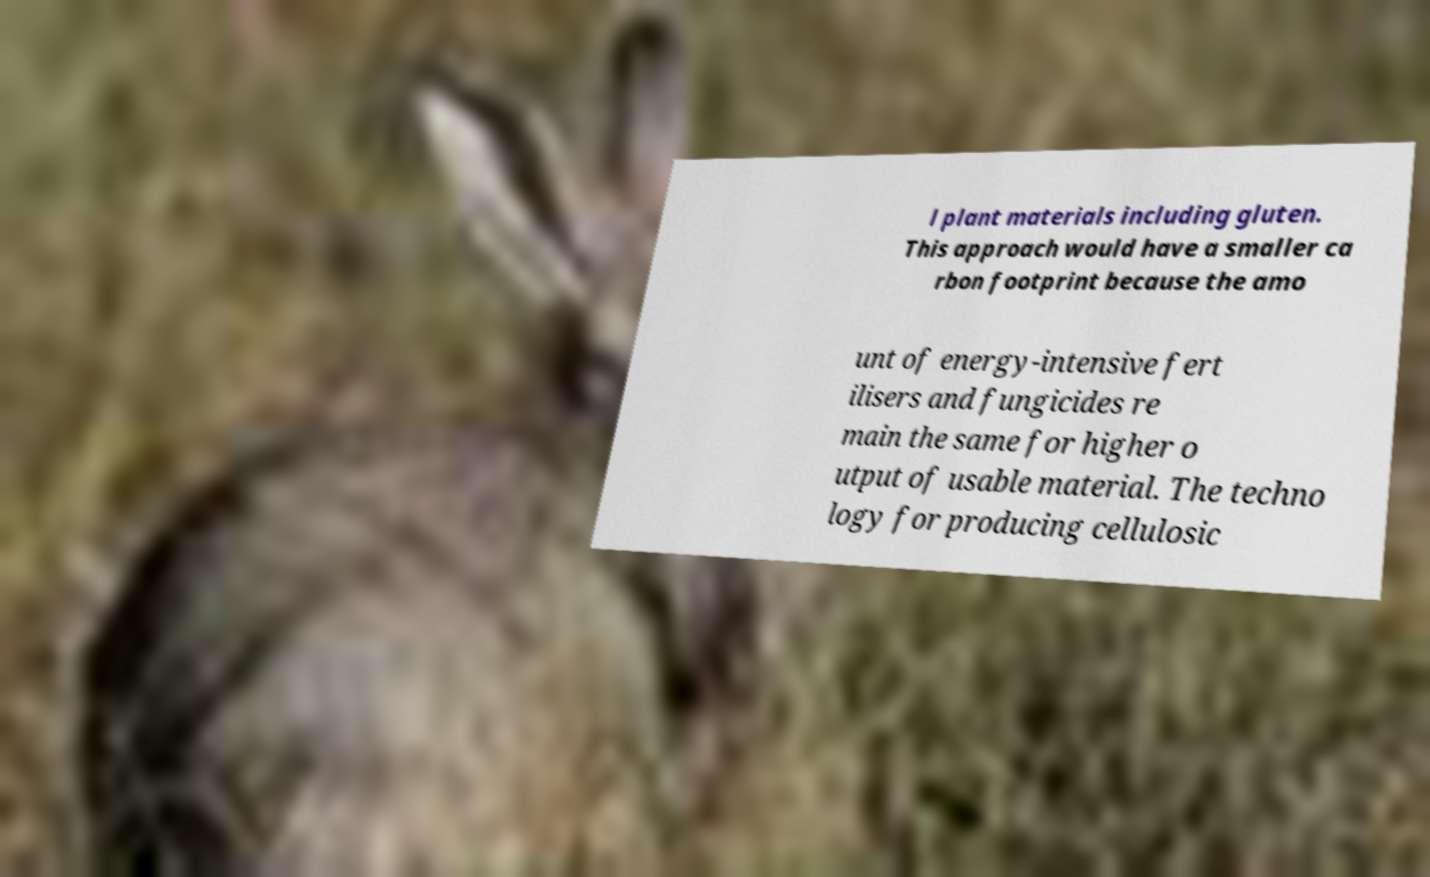What messages or text are displayed in this image? I need them in a readable, typed format. l plant materials including gluten. This approach would have a smaller ca rbon footprint because the amo unt of energy-intensive fert ilisers and fungicides re main the same for higher o utput of usable material. The techno logy for producing cellulosic 